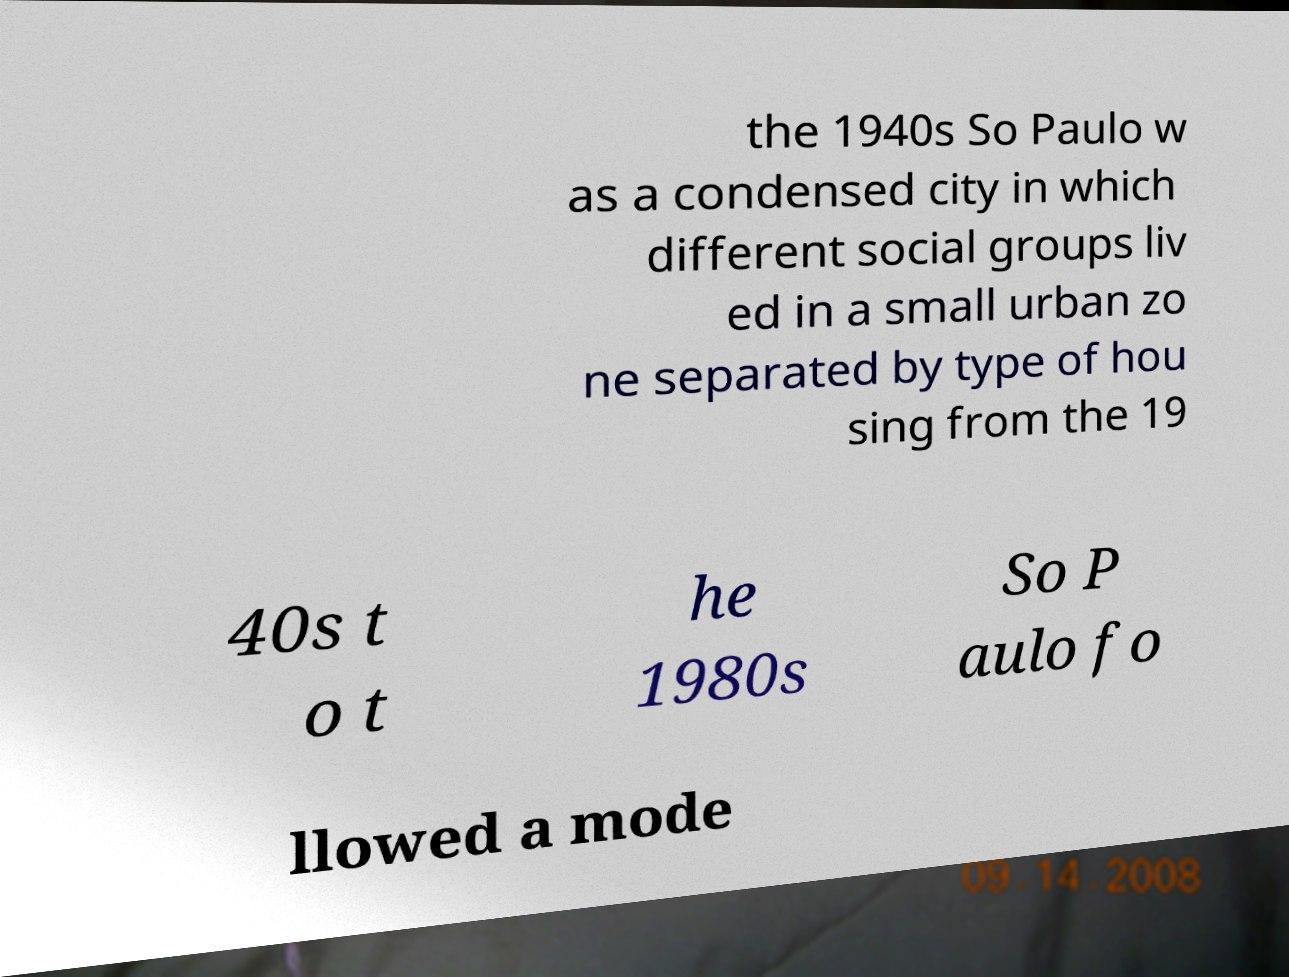Please identify and transcribe the text found in this image. the 1940s So Paulo w as a condensed city in which different social groups liv ed in a small urban zo ne separated by type of hou sing from the 19 40s t o t he 1980s So P aulo fo llowed a mode 